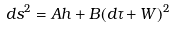<formula> <loc_0><loc_0><loc_500><loc_500>d s ^ { 2 } = A h + B ( d \tau + W ) ^ { 2 }</formula> 